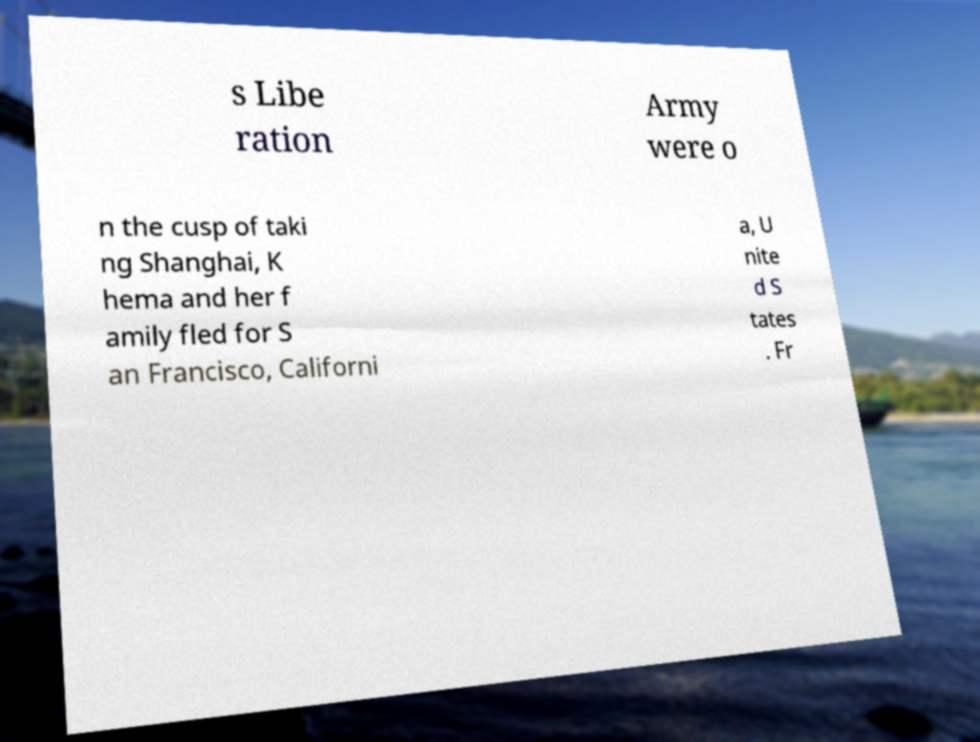What messages or text are displayed in this image? I need them in a readable, typed format. s Libe ration Army were o n the cusp of taki ng Shanghai, K hema and her f amily fled for S an Francisco, Californi a, U nite d S tates . Fr 